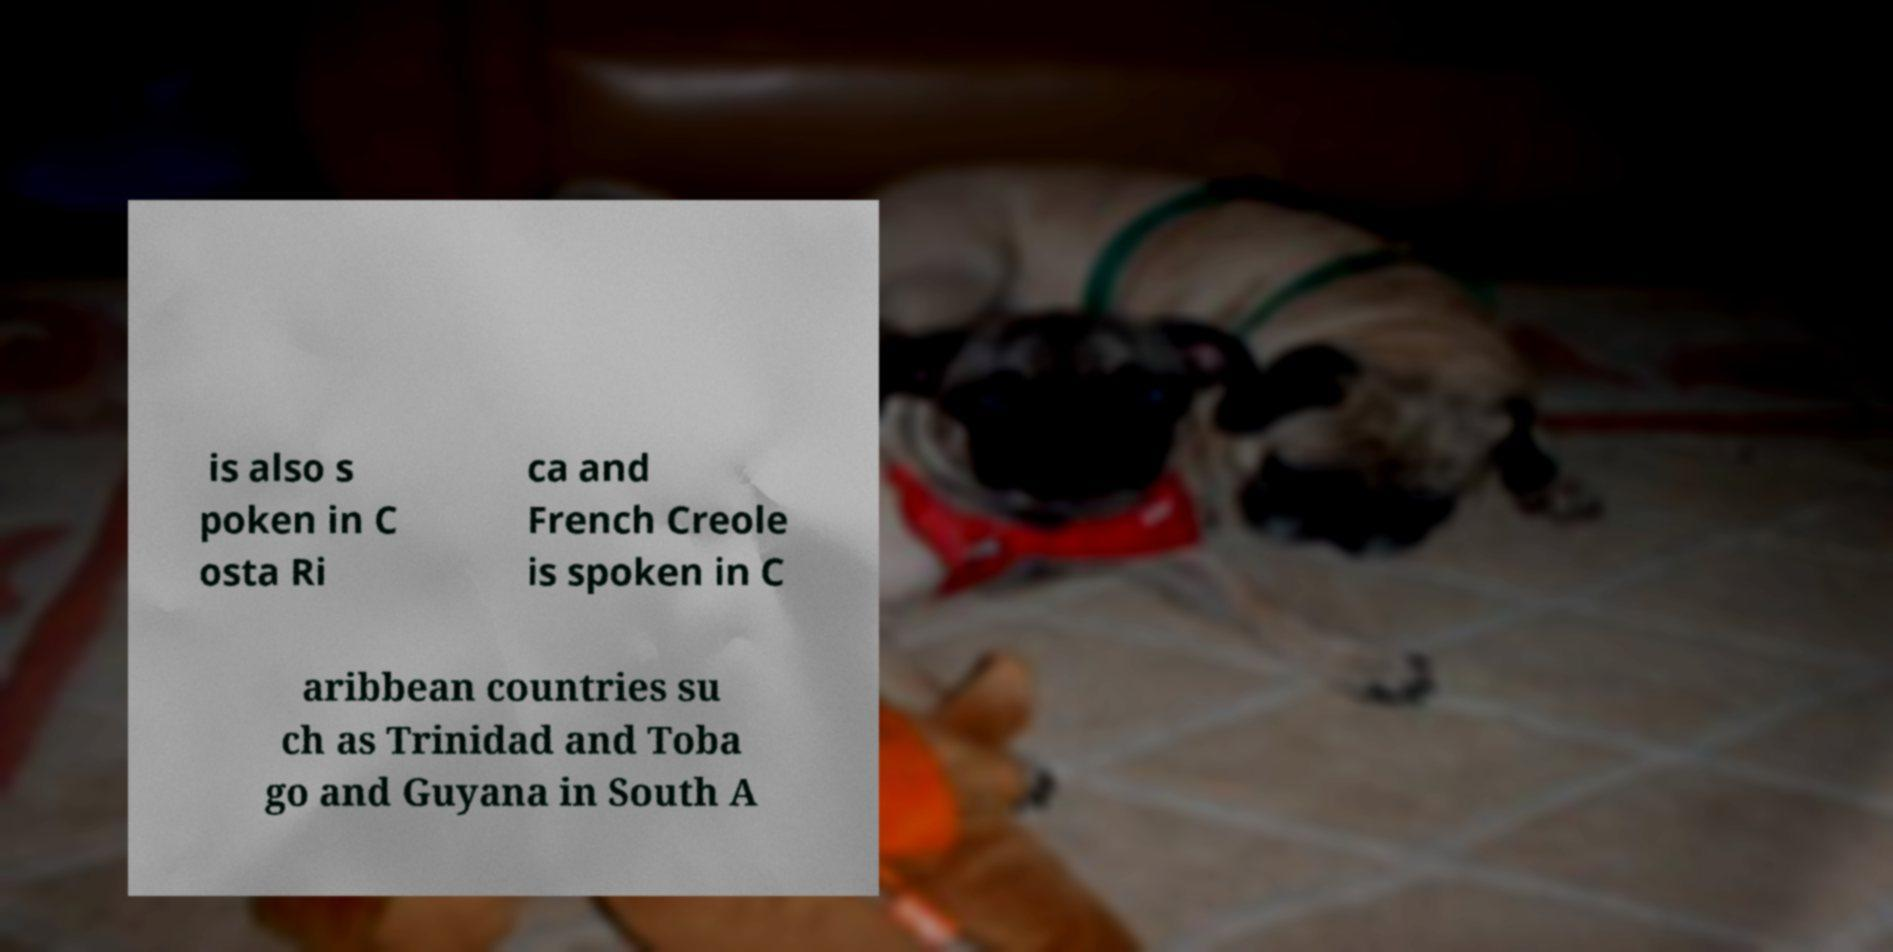Can you accurately transcribe the text from the provided image for me? is also s poken in C osta Ri ca and French Creole is spoken in C aribbean countries su ch as Trinidad and Toba go and Guyana in South A 